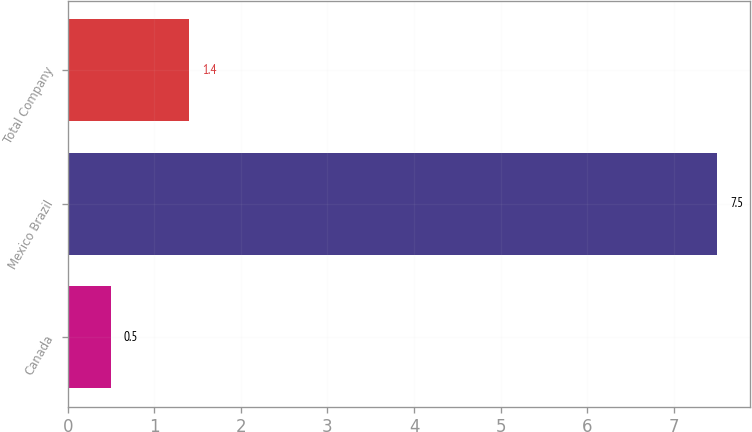Convert chart to OTSL. <chart><loc_0><loc_0><loc_500><loc_500><bar_chart><fcel>Canada<fcel>Mexico Brazil<fcel>Total Company<nl><fcel>0.5<fcel>7.5<fcel>1.4<nl></chart> 